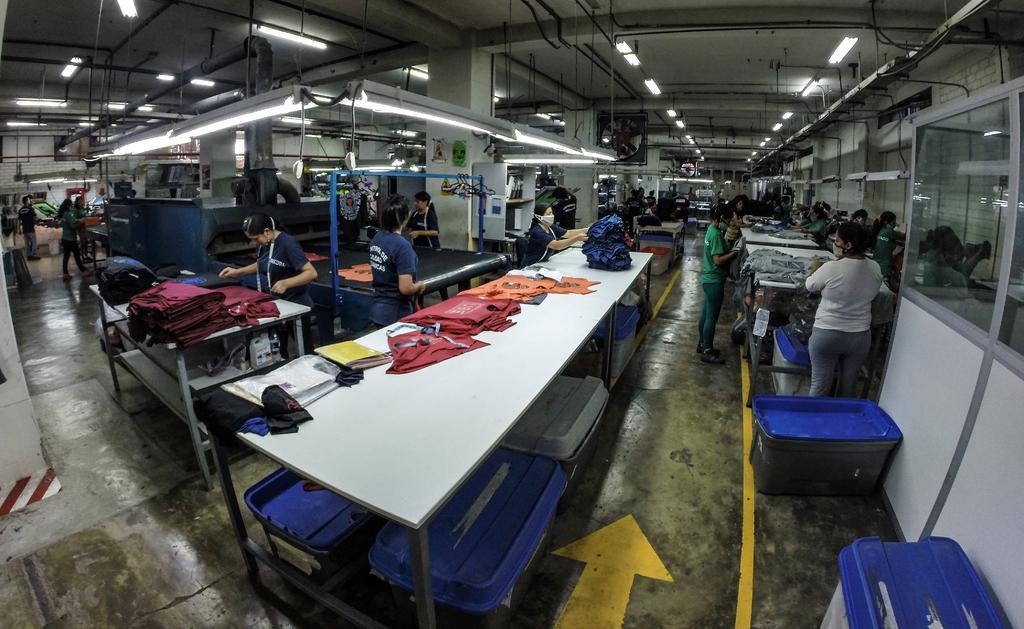Describe this image in one or two sentences. This image consists of lights at the top. There are tables in the middle. There are so many clothes on tables. There are so many persons near tables. They are stretching something. 